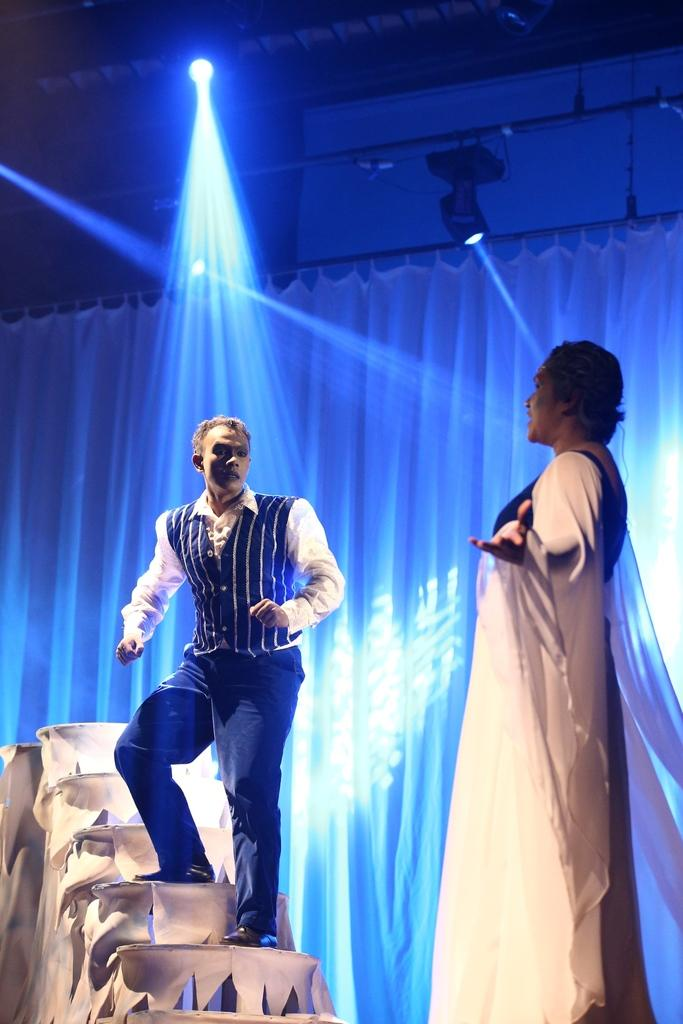What is the person on the left side of the image doing? The person is standing on the stairs on the left side of the image. What is the man on the right side of the image doing? There is no information about what the man is doing, but he is present on the right side of the image. What can be seen in the background of the image? There is a curtain, a light, and a wall in the background of the image. What type of soda is the person holding in the image? There is no soda present in the image; the person is standing on the stairs. How many birds are visible on the wall in the image? There are no birds visible on the wall in the image. 